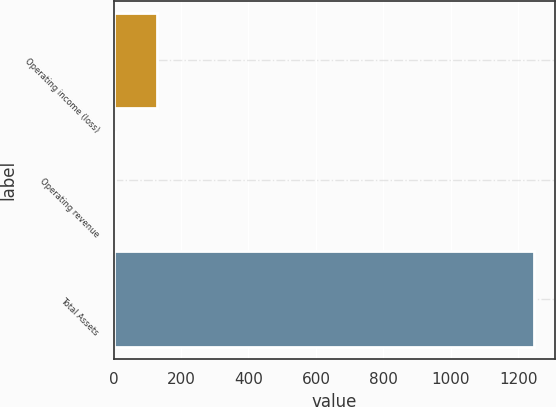Convert chart to OTSL. <chart><loc_0><loc_0><loc_500><loc_500><bar_chart><fcel>Operating income (loss)<fcel>Operating revenue<fcel>Total Assets<nl><fcel>127.5<fcel>3<fcel>1248<nl></chart> 